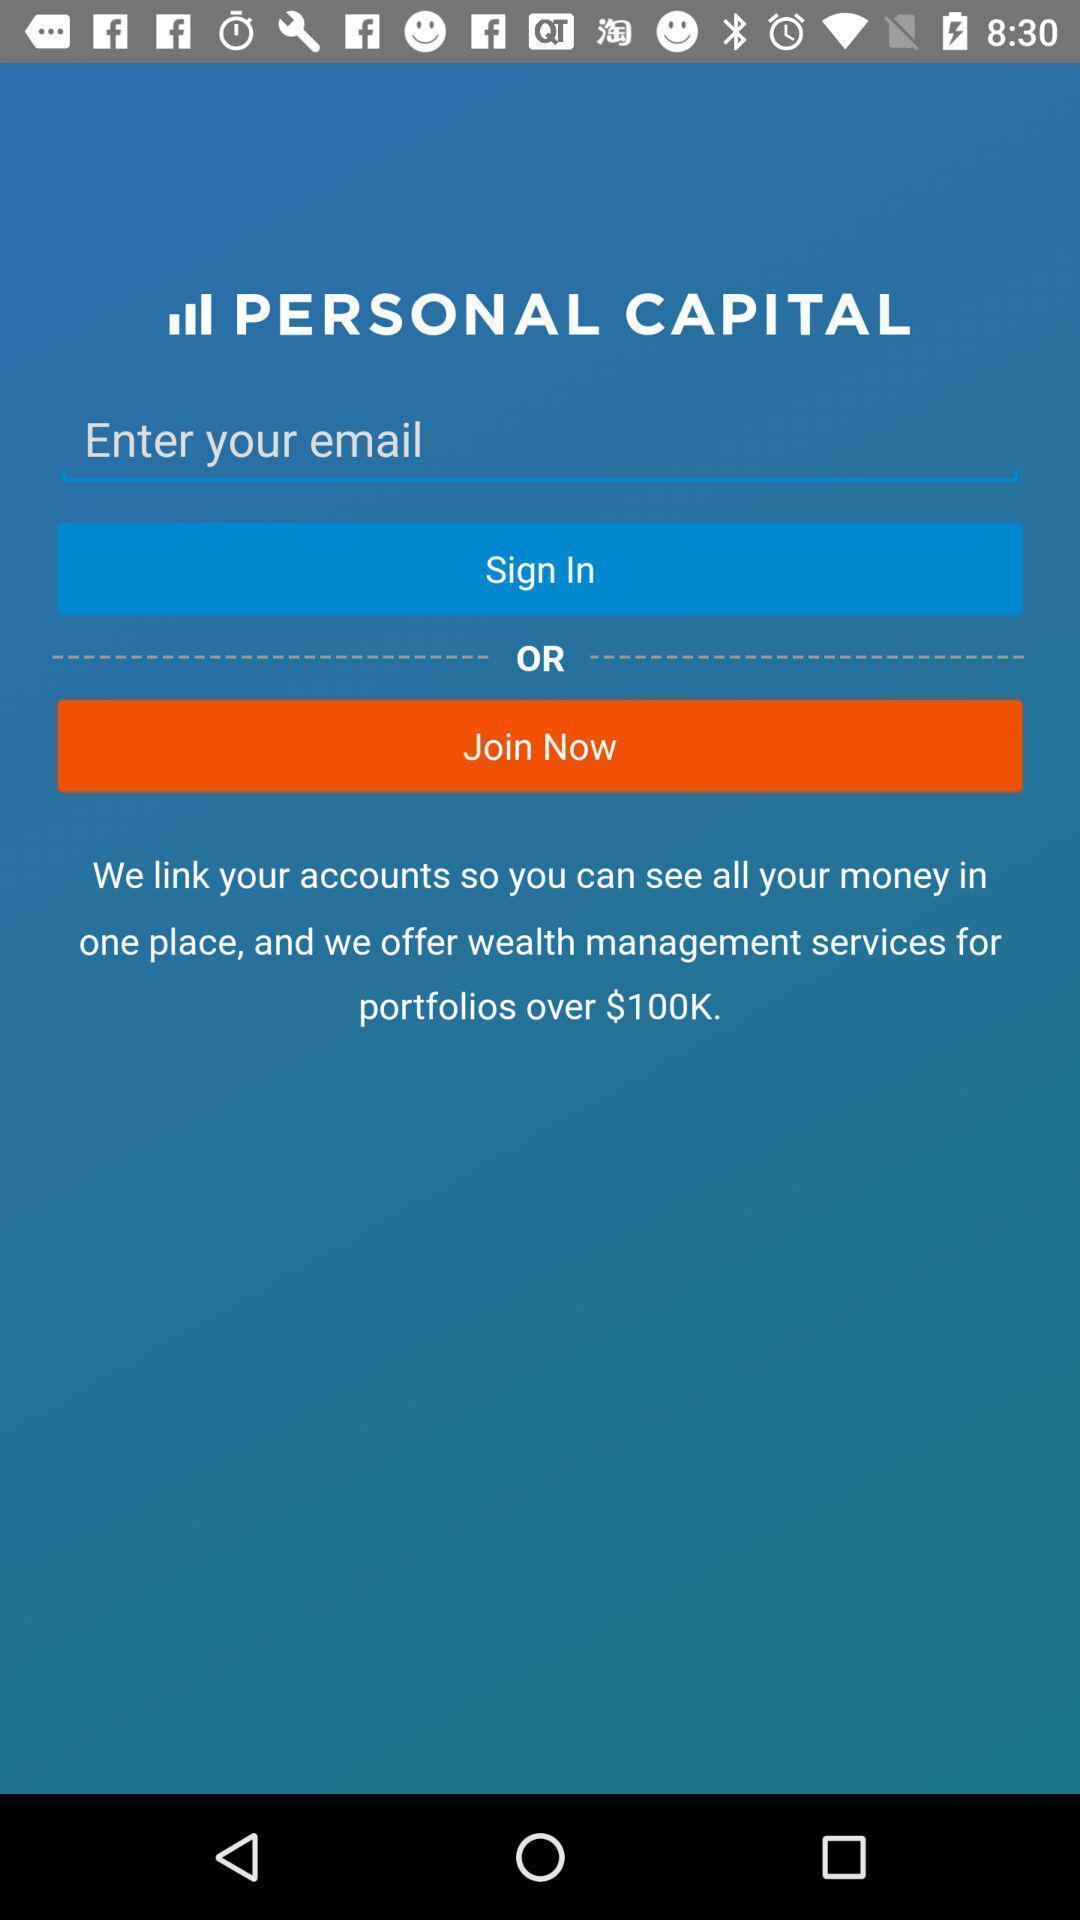Give me a summary of this screen capture. Sign in page. 